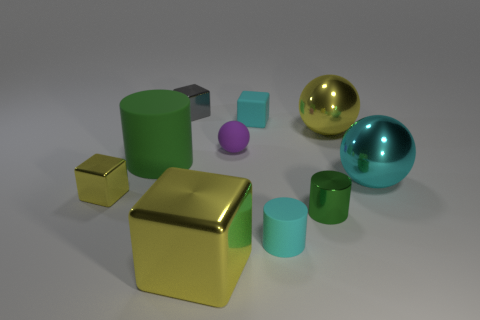What is the big green object made of?
Provide a short and direct response. Rubber. Are there more small cylinders behind the large green thing than matte blocks?
Provide a succinct answer. No. Is there a small matte cylinder?
Make the answer very short. Yes. What number of other things are there of the same shape as the tiny purple thing?
Offer a very short reply. 2. There is a matte cylinder to the right of the tiny matte block; is its color the same as the matte object that is behind the tiny purple matte ball?
Provide a short and direct response. Yes. What is the size of the cyan thing that is left of the tiny cyan thing that is in front of the cyan thing that is behind the big yellow shiny sphere?
Provide a succinct answer. Small. There is a cyan thing that is both in front of the cyan rubber block and to the left of the yellow shiny sphere; what shape is it?
Provide a succinct answer. Cylinder. Are there the same number of large yellow spheres that are left of the tiny cyan cylinder and cyan matte things in front of the green metal cylinder?
Offer a very short reply. No. Is there a yellow block that has the same material as the cyan block?
Your response must be concise. No. Do the green thing left of the purple ball and the gray cube have the same material?
Your response must be concise. No. 